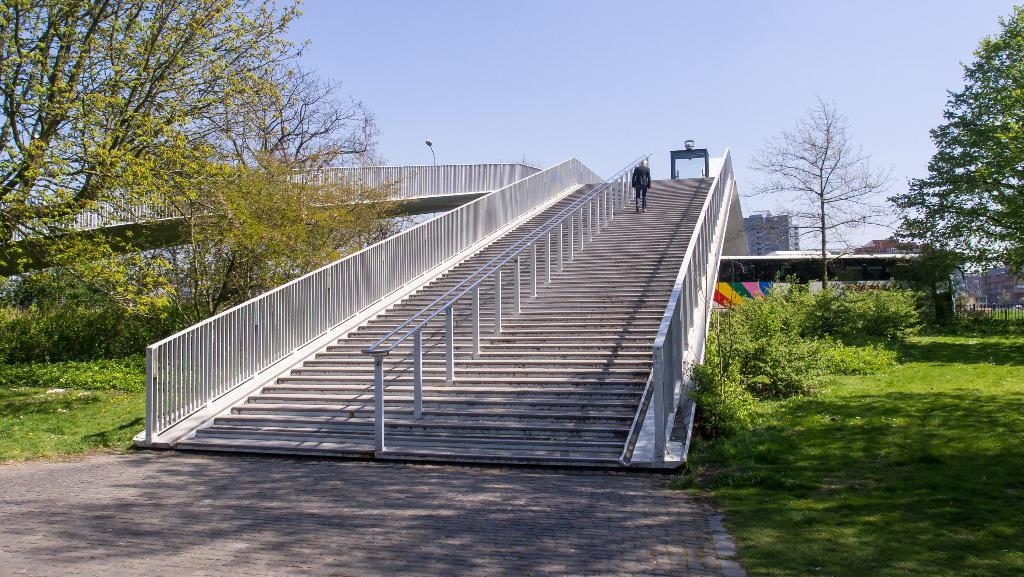What can be seen in the image that people use to move between different levels? There are stairs in the image that people use to move between different levels. What is the man in the image doing? A man is moving up on the stairs in the image. What type of vegetation is present around the stairs? There is grass, plants, and trees around the stairs in the image. What can be seen in the background of the image? There is a building in the background of the image. How many chairs are visible in the image? There are no chairs present in the image. What is the reason for the man moving up on the stairs in the image? The image does not provide any information about the man's reason for moving up on the stairs. 